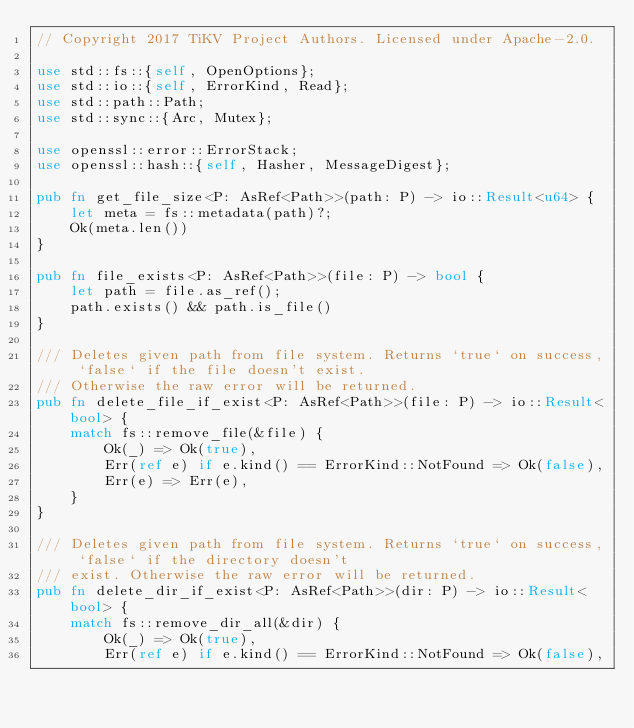Convert code to text. <code><loc_0><loc_0><loc_500><loc_500><_Rust_>// Copyright 2017 TiKV Project Authors. Licensed under Apache-2.0.

use std::fs::{self, OpenOptions};
use std::io::{self, ErrorKind, Read};
use std::path::Path;
use std::sync::{Arc, Mutex};

use openssl::error::ErrorStack;
use openssl::hash::{self, Hasher, MessageDigest};

pub fn get_file_size<P: AsRef<Path>>(path: P) -> io::Result<u64> {
    let meta = fs::metadata(path)?;
    Ok(meta.len())
}

pub fn file_exists<P: AsRef<Path>>(file: P) -> bool {
    let path = file.as_ref();
    path.exists() && path.is_file()
}

/// Deletes given path from file system. Returns `true` on success, `false` if the file doesn't exist.
/// Otherwise the raw error will be returned.
pub fn delete_file_if_exist<P: AsRef<Path>>(file: P) -> io::Result<bool> {
    match fs::remove_file(&file) {
        Ok(_) => Ok(true),
        Err(ref e) if e.kind() == ErrorKind::NotFound => Ok(false),
        Err(e) => Err(e),
    }
}

/// Deletes given path from file system. Returns `true` on success, `false` if the directory doesn't
/// exist. Otherwise the raw error will be returned.
pub fn delete_dir_if_exist<P: AsRef<Path>>(dir: P) -> io::Result<bool> {
    match fs::remove_dir_all(&dir) {
        Ok(_) => Ok(true),
        Err(ref e) if e.kind() == ErrorKind::NotFound => Ok(false),</code> 